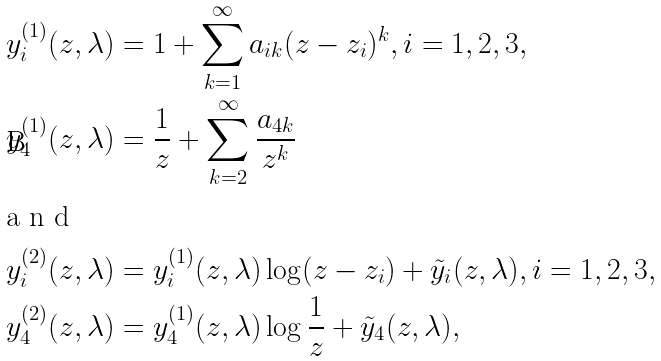<formula> <loc_0><loc_0><loc_500><loc_500>y ^ { ( 1 ) } _ { i } ( z , \lambda ) & = 1 + \sum _ { k = 1 } ^ { \infty } a _ { i k } ( z - z _ { i } ) ^ { k } , i = 1 , 2 , 3 , \\ y ^ { ( 1 ) } _ { 4 } ( z , \lambda ) & = \frac { 1 } { z } + \sum _ { k = 2 } ^ { \infty } \frac { a _ { 4 k } } { z ^ { k } } \\ \intertext { a n d } y ^ { ( 2 ) } _ { i } ( z , \lambda ) & = y ^ { ( 1 ) } _ { i } ( z , \lambda ) \log ( z - z _ { i } ) + \tilde { y } _ { i } ( z , \lambda ) , i = 1 , 2 , 3 , \\ y ^ { ( 2 ) } _ { 4 } ( z , \lambda ) & = y ^ { ( 1 ) } _ { 4 } ( z , \lambda ) \log \frac { 1 } { z } + \tilde { y } _ { 4 } ( z , \lambda ) ,</formula> 